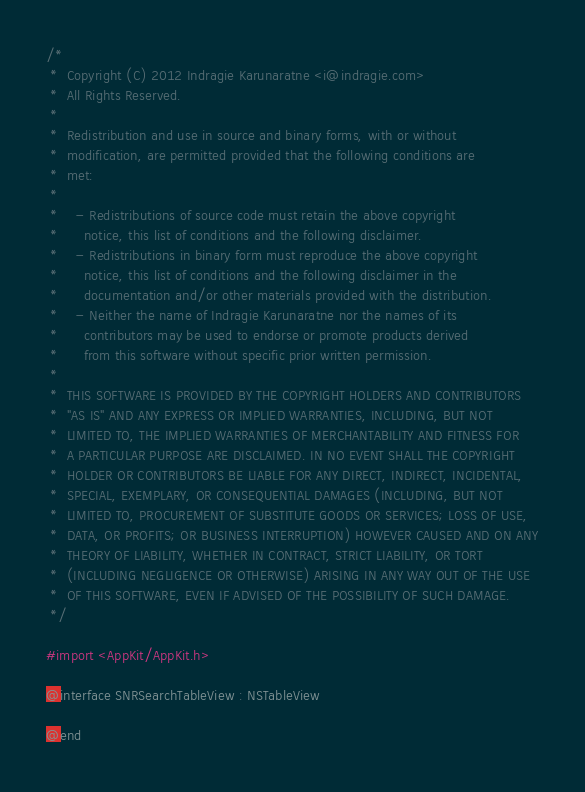<code> <loc_0><loc_0><loc_500><loc_500><_C_>/*
 *  Copyright (C) 2012 Indragie Karunaratne <i@indragie.com>
 *  All Rights Reserved.
 *
 *  Redistribution and use in source and binary forms, with or without
 *  modification, are permitted provided that the following conditions are
 *  met:
 *
 *    - Redistributions of source code must retain the above copyright
 *      notice, this list of conditions and the following disclaimer.
 *    - Redistributions in binary form must reproduce the above copyright
 *      notice, this list of conditions and the following disclaimer in the
 *      documentation and/or other materials provided with the distribution.
 *    - Neither the name of Indragie Karunaratne nor the names of its
 *      contributors may be used to endorse or promote products derived
 *      from this software without specific prior written permission.
 *
 *  THIS SOFTWARE IS PROVIDED BY THE COPYRIGHT HOLDERS AND CONTRIBUTORS
 *  "AS IS" AND ANY EXPRESS OR IMPLIED WARRANTIES, INCLUDING, BUT NOT
 *  LIMITED TO, THE IMPLIED WARRANTIES OF MERCHANTABILITY AND FITNESS FOR
 *  A PARTICULAR PURPOSE ARE DISCLAIMED. IN NO EVENT SHALL THE COPYRIGHT
 *  HOLDER OR CONTRIBUTORS BE LIABLE FOR ANY DIRECT, INDIRECT, INCIDENTAL,
 *  SPECIAL, EXEMPLARY, OR CONSEQUENTIAL DAMAGES (INCLUDING, BUT NOT
 *  LIMITED TO, PROCUREMENT OF SUBSTITUTE GOODS OR SERVICES; LOSS OF USE,
 *  DATA, OR PROFITS; OR BUSINESS INTERRUPTION) HOWEVER CAUSED AND ON ANY
 *  THEORY OF LIABILITY, WHETHER IN CONTRACT, STRICT LIABILITY, OR TORT
 *  (INCLUDING NEGLIGENCE OR OTHERWISE) ARISING IN ANY WAY OUT OF THE USE
 *  OF THIS SOFTWARE, EVEN IF ADVISED OF THE POSSIBILITY OF SUCH DAMAGE.
 */

#import <AppKit/AppKit.h>

@interface SNRSearchTableView : NSTableView

@end</code> 